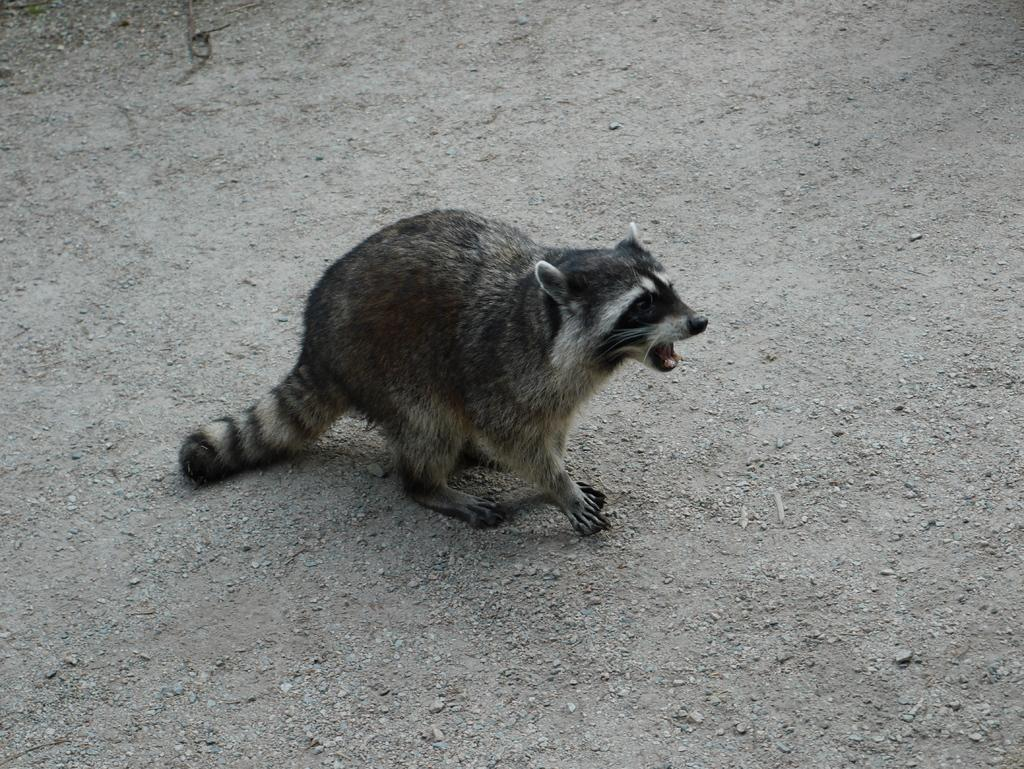What type of creature is present in the image? There is an animal in the image. Where is the animal located in the image? The animal is on the ground. How many toes can be seen on the goose in the image? There is no goose present in the image, and therefore no toes can be observed. 